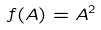<formula> <loc_0><loc_0><loc_500><loc_500>f ( A ) = A ^ { 2 }</formula> 